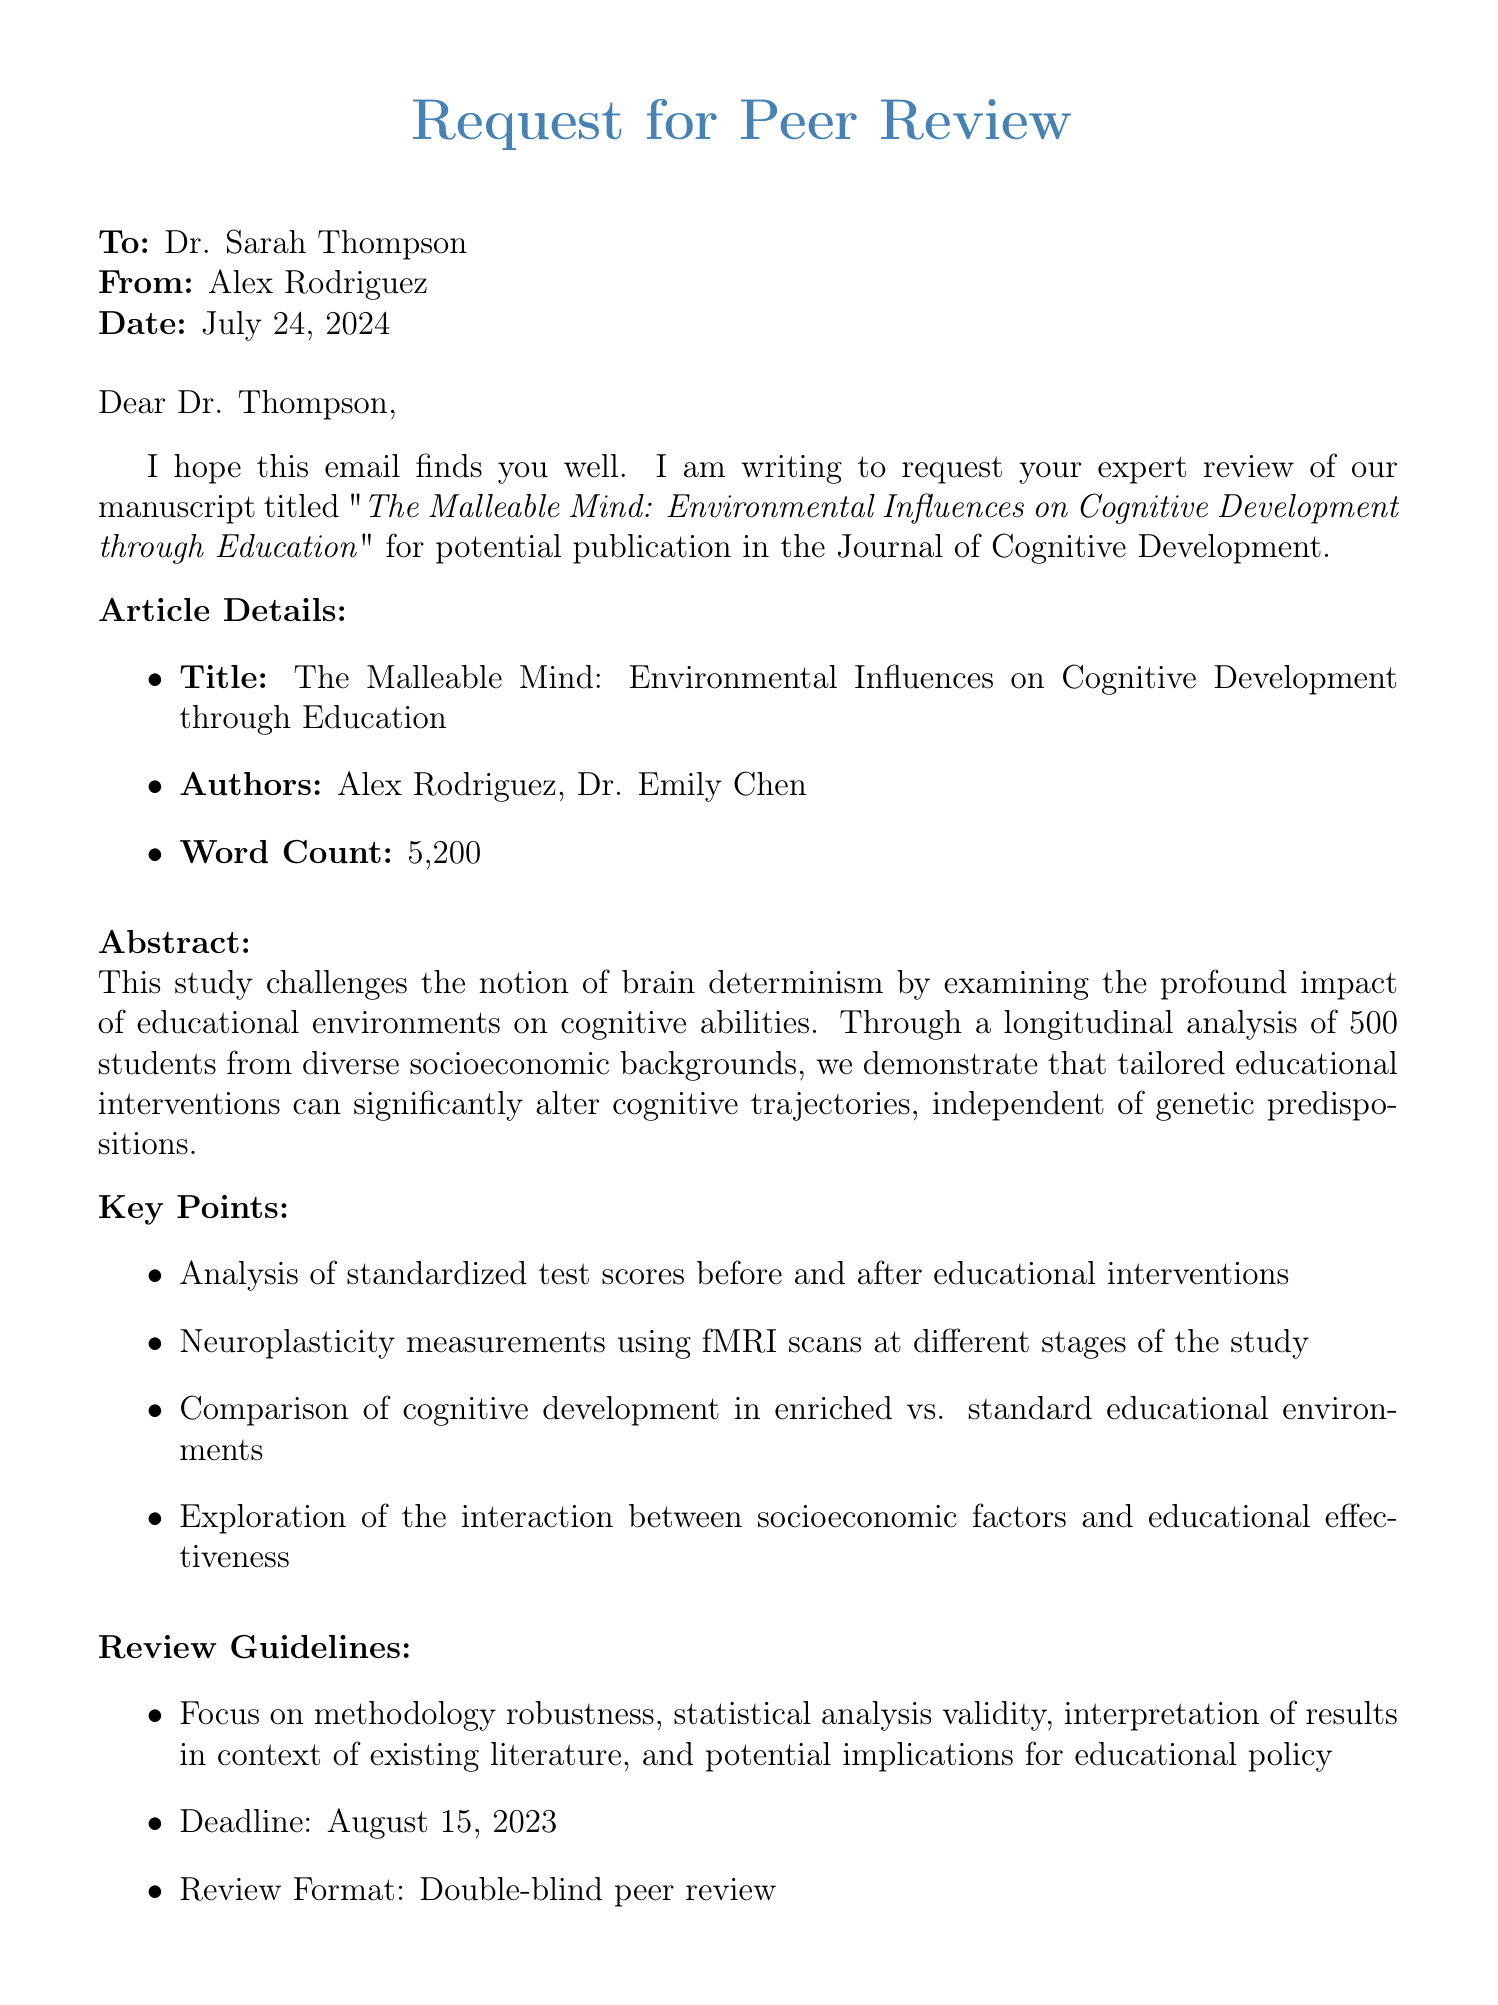What is the title of the article? The title of the article is explicitly stated in the document as part of the article details.
Answer: The Malleable Mind: Environmental Influences on Cognitive Development through Education Who are the authors of the manuscript? The authors' names are listed in the article details section of the document.
Answer: Alex Rodriguez, Dr. Emily Chen What is the word count of the manuscript? The word count is a specific detail mentioned in the article details of the document.
Answer: 5,200 What is the abstract's main challenge? The abstract lists a specific claim about brain determinism that the study addresses.
Answer: Brain determinism What is the review deadline? The deadline for the review is indicated in the review guidelines section.
Answer: August 15, 2023 What methodological focus areas are mentioned for review? The review guidelines list specific areas of focus relevant to the methodology.
Answer: Methodology robustness What type of review format is requested? The review format is specified in the review guidelines.
Answer: Double-blind peer review Which socioeconomic factor aspect is explored in the article? Key points note an exploration regarding the relationship between socioeconomic factors and educational effectiveness.
Answer: Socioeconomic factors What is the primary location of the sender's affiliation? The sender's affiliation provides geographic information about their university.
Answer: University of California, Berkeley 